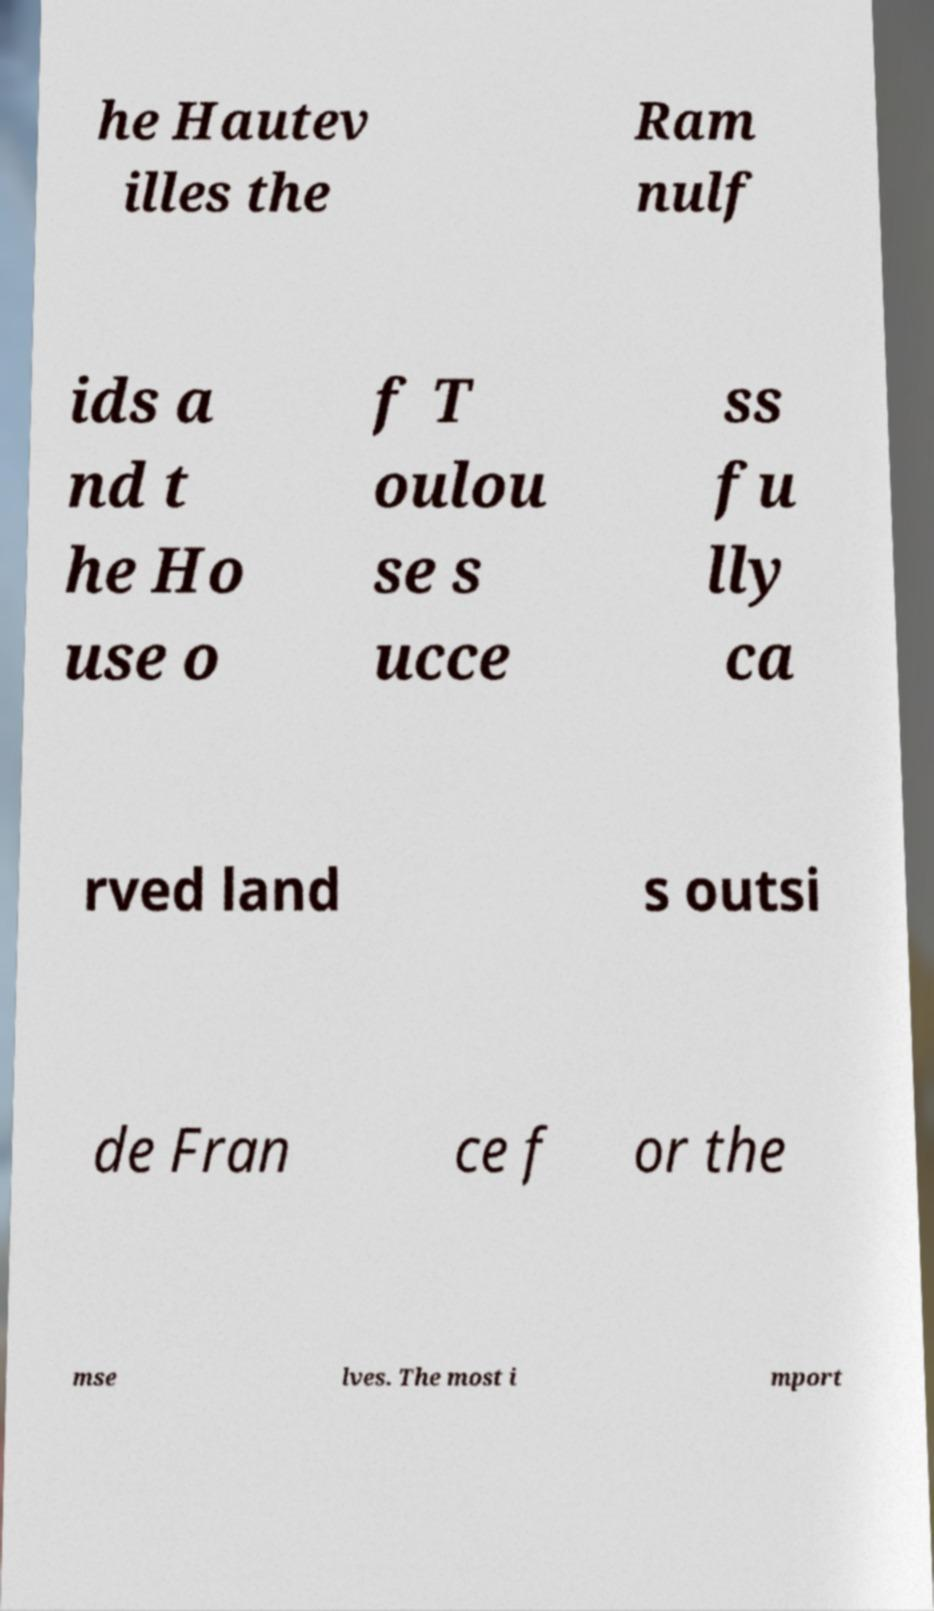Please read and relay the text visible in this image. What does it say? he Hautev illes the Ram nulf ids a nd t he Ho use o f T oulou se s ucce ss fu lly ca rved land s outsi de Fran ce f or the mse lves. The most i mport 